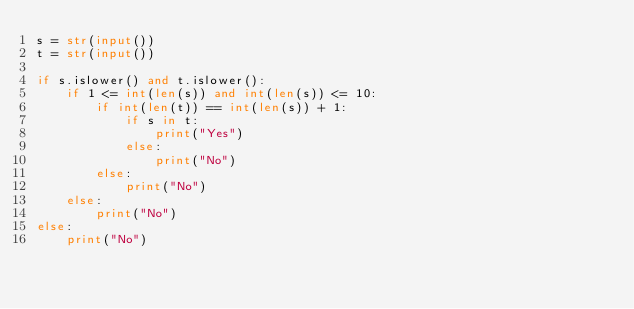<code> <loc_0><loc_0><loc_500><loc_500><_Python_>s = str(input())
t = str(input())

if s.islower() and t.islower():
    if 1 <= int(len(s)) and int(len(s)) <= 10:
        if int(len(t)) == int(len(s)) + 1:
            if s in t:
                print("Yes")
            else:
                print("No")
        else:
            print("No")
    else:
        print("No")
else:
    print("No")</code> 